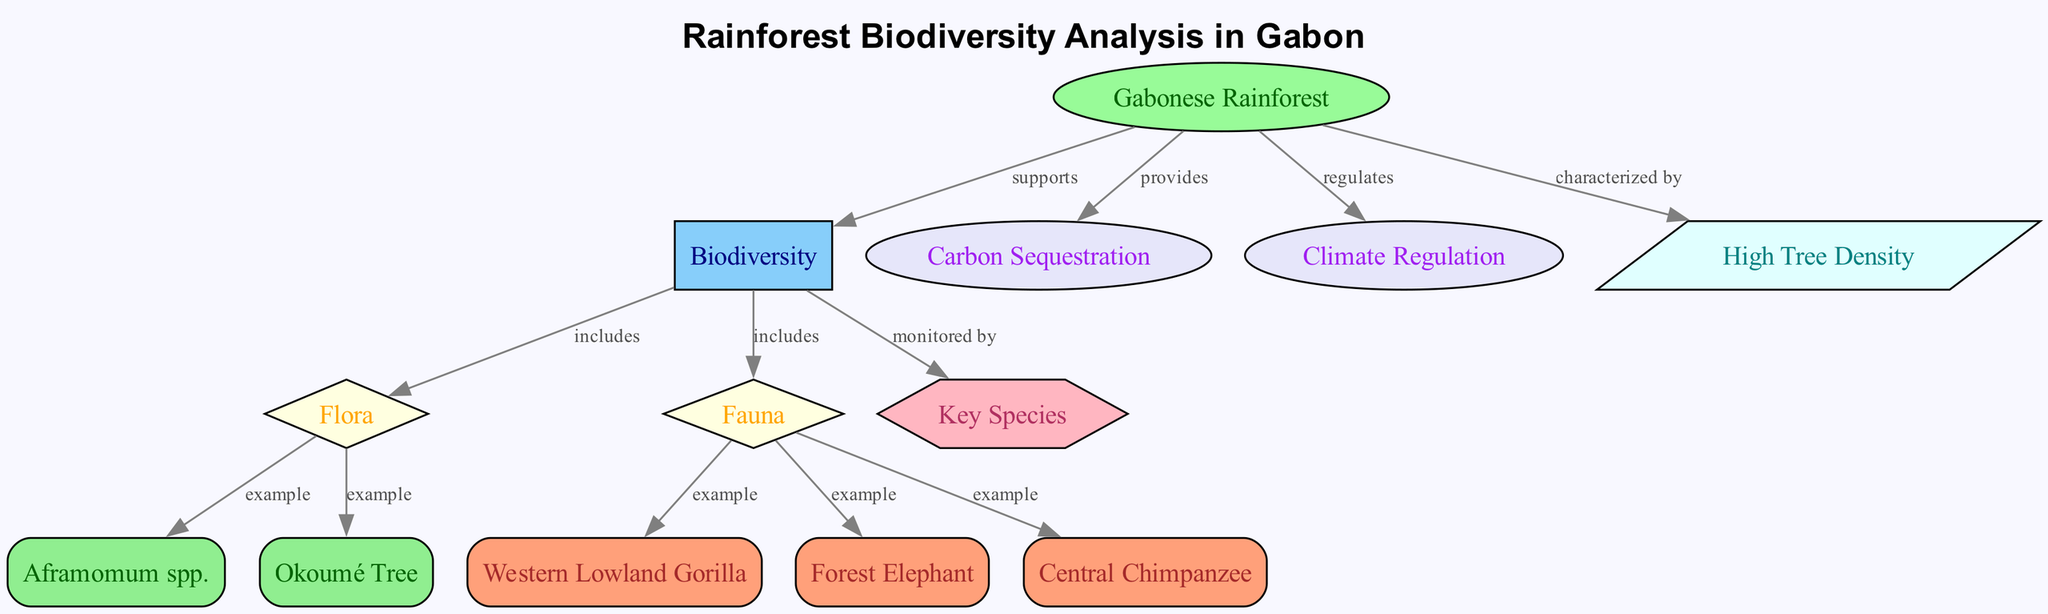What is the main environment highlighted in the diagram? The diagram identifies the "Gabonese Rainforest" as the main environment. This is found at the top of the diagram as a node labeled "Gabonese Rainforest."
Answer: Gabonese Rainforest How many key species examples are listed under fauna? There are three examples of key species under the category of fauna: Western Lowland Gorilla, Forest Elephant, and Central Chimpanzee. Each of these is connected to the fauna category node.
Answer: 3 What ecological benefit provided by the rainforest relates to carbon? The diagram indicates that the "Gabonese Rainforest" provides "Carbon Sequestration" as a benefit. This is shown through an edge connecting the rainforest node to the carbon node.
Answer: Carbon Sequestration Which tree species is an example of flora in the Gabonese rainforest? The "Okoumé Tree" is mentioned as an example under the flora category. This is reflected in the diagram where it is connected to the flora node.
Answer: Okoumé Tree What type of regulation does the Gabonese rainforest perform? The diagram states that the rainforest "regulates" the climate, shown through a direct edge linking the rainforest node to the climate node.
Answer: Climate Regulation What characteristic is associated with the Gabonese rainforest? The diagram notes "High Tree Density" as a characteristic of the Gabonese rainforest. This is displayed through an edge connecting the rainforest node to the characteristic node.
Answer: High Tree Density Which species is monitored as part of biodiversity in the diagram? The node labeled "Key Species" indicates that species are monitored by the biodiversity node, showing the relationship through an edge. This implies that various species, including the key examples, contribute to biodiversity.
Answer: Key Species What are the two main categories that biodiversity includes? Biodiversity includes "Flora" and "Fauna," which are represented as categories connected to the biodiversity node in the diagram.
Answer: Flora and Fauna 